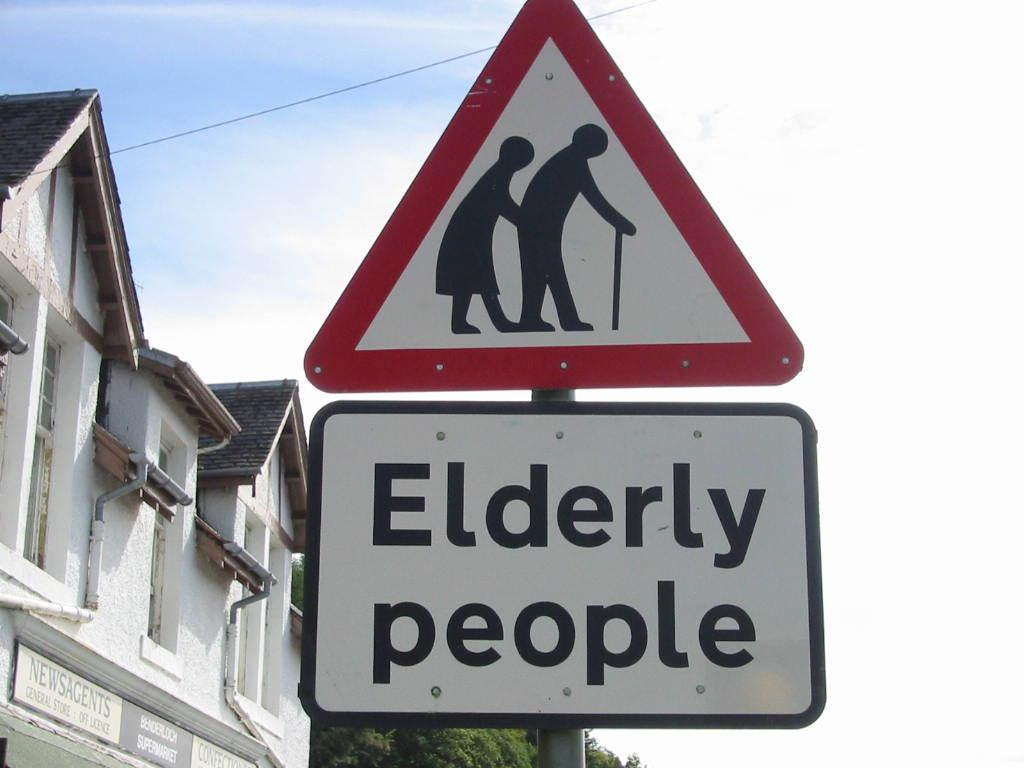<image>
Provide a brief description of the given image. a sign for Elderly People shows a graphic of people walking with a cane 